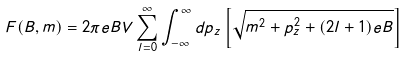<formula> <loc_0><loc_0><loc_500><loc_500>F ( B , m ) = 2 \pi e B V \sum _ { l = 0 } ^ { \infty } \int _ { - \infty } ^ { \infty } d p _ { z } \left [ \sqrt { m ^ { 2 } + p _ { z } ^ { 2 } + ( 2 l + 1 ) e B } \right ]</formula> 